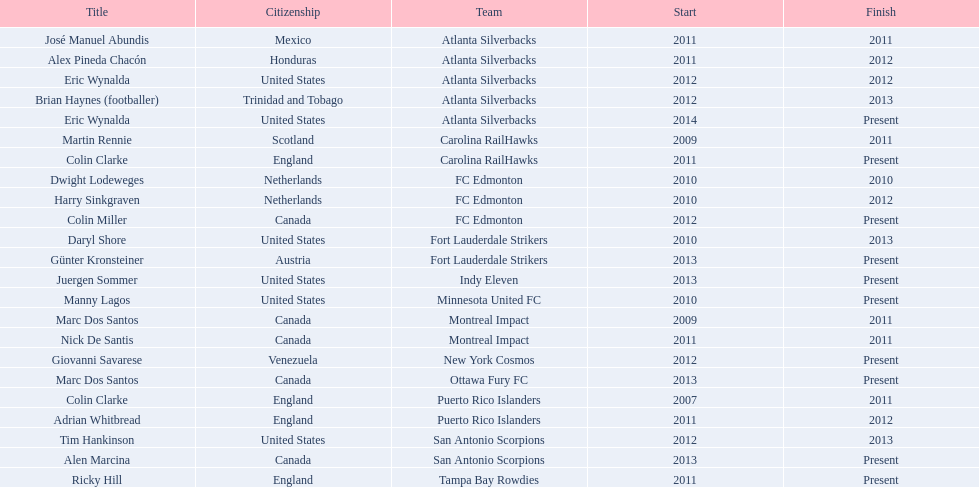What year did marc dos santos start as coach? 2009. Which other starting years correspond with this year? 2009. Who was the other coach with this starting year Martin Rennie. 